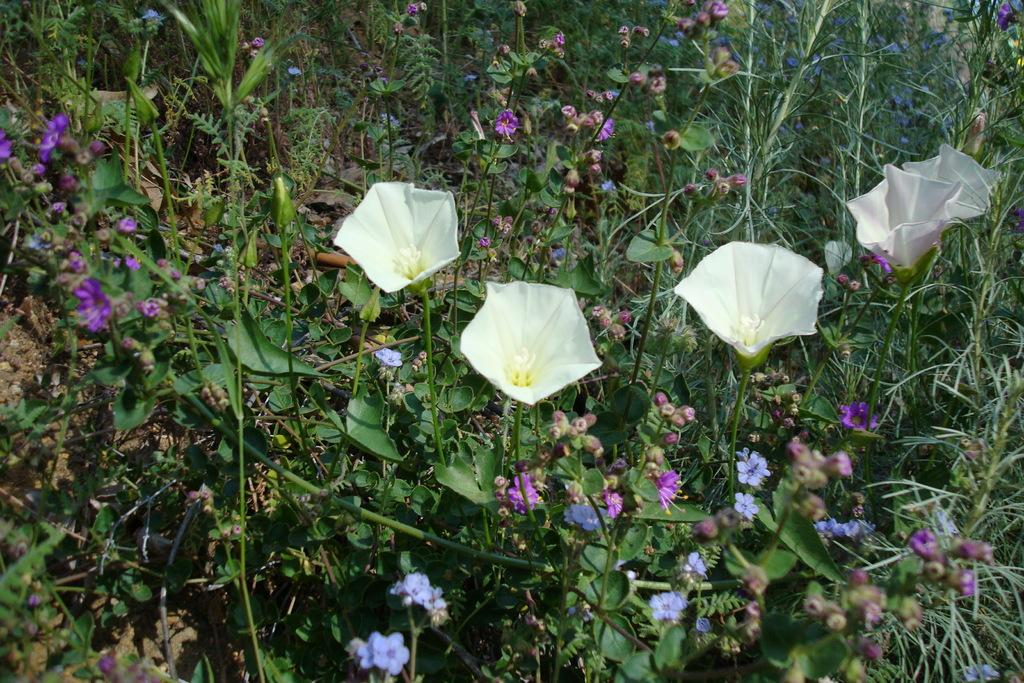What type of plants can be seen in the image? There are flower plants in the image. How are the flower plants distributed in the land? The flower plants are spread all over the land. What type of building can be seen in the image? There is no building present in the image; it only features flower plants spread across the land. What kind of ball is being used by the flower plants in the image? There is no ball present in the image, as it only features flower plants. 